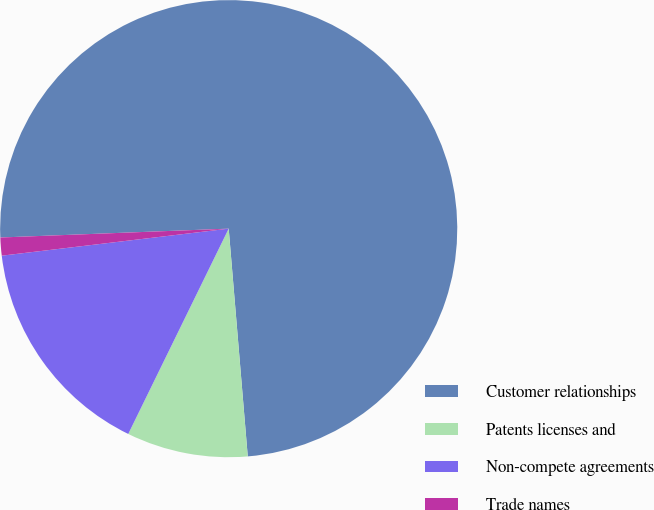Convert chart to OTSL. <chart><loc_0><loc_0><loc_500><loc_500><pie_chart><fcel>Customer relationships<fcel>Patents licenses and<fcel>Non-compete agreements<fcel>Trade names<nl><fcel>74.28%<fcel>8.57%<fcel>15.87%<fcel>1.27%<nl></chart> 